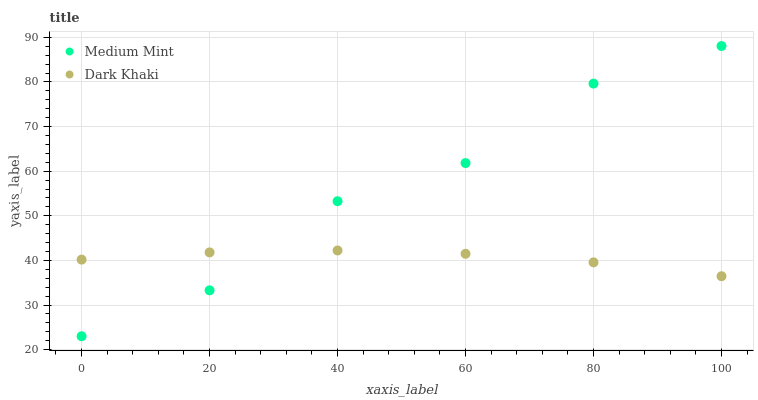Does Dark Khaki have the minimum area under the curve?
Answer yes or no. Yes. Does Medium Mint have the maximum area under the curve?
Answer yes or no. Yes. Does Dark Khaki have the maximum area under the curve?
Answer yes or no. No. Is Dark Khaki the smoothest?
Answer yes or no. Yes. Is Medium Mint the roughest?
Answer yes or no. Yes. Is Dark Khaki the roughest?
Answer yes or no. No. Does Medium Mint have the lowest value?
Answer yes or no. Yes. Does Dark Khaki have the lowest value?
Answer yes or no. No. Does Medium Mint have the highest value?
Answer yes or no. Yes. Does Dark Khaki have the highest value?
Answer yes or no. No. Does Medium Mint intersect Dark Khaki?
Answer yes or no. Yes. Is Medium Mint less than Dark Khaki?
Answer yes or no. No. Is Medium Mint greater than Dark Khaki?
Answer yes or no. No. 